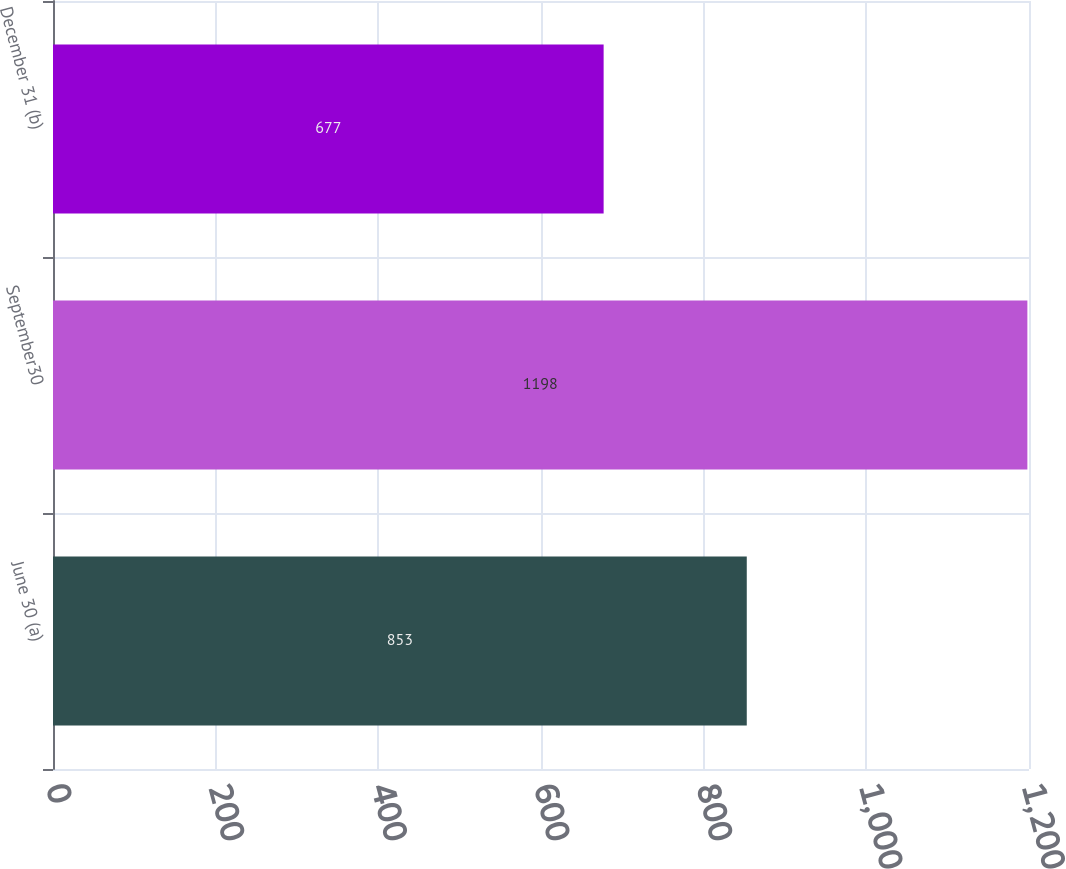Convert chart. <chart><loc_0><loc_0><loc_500><loc_500><bar_chart><fcel>June 30 (a)<fcel>September30<fcel>December 31 (b)<nl><fcel>853<fcel>1198<fcel>677<nl></chart> 